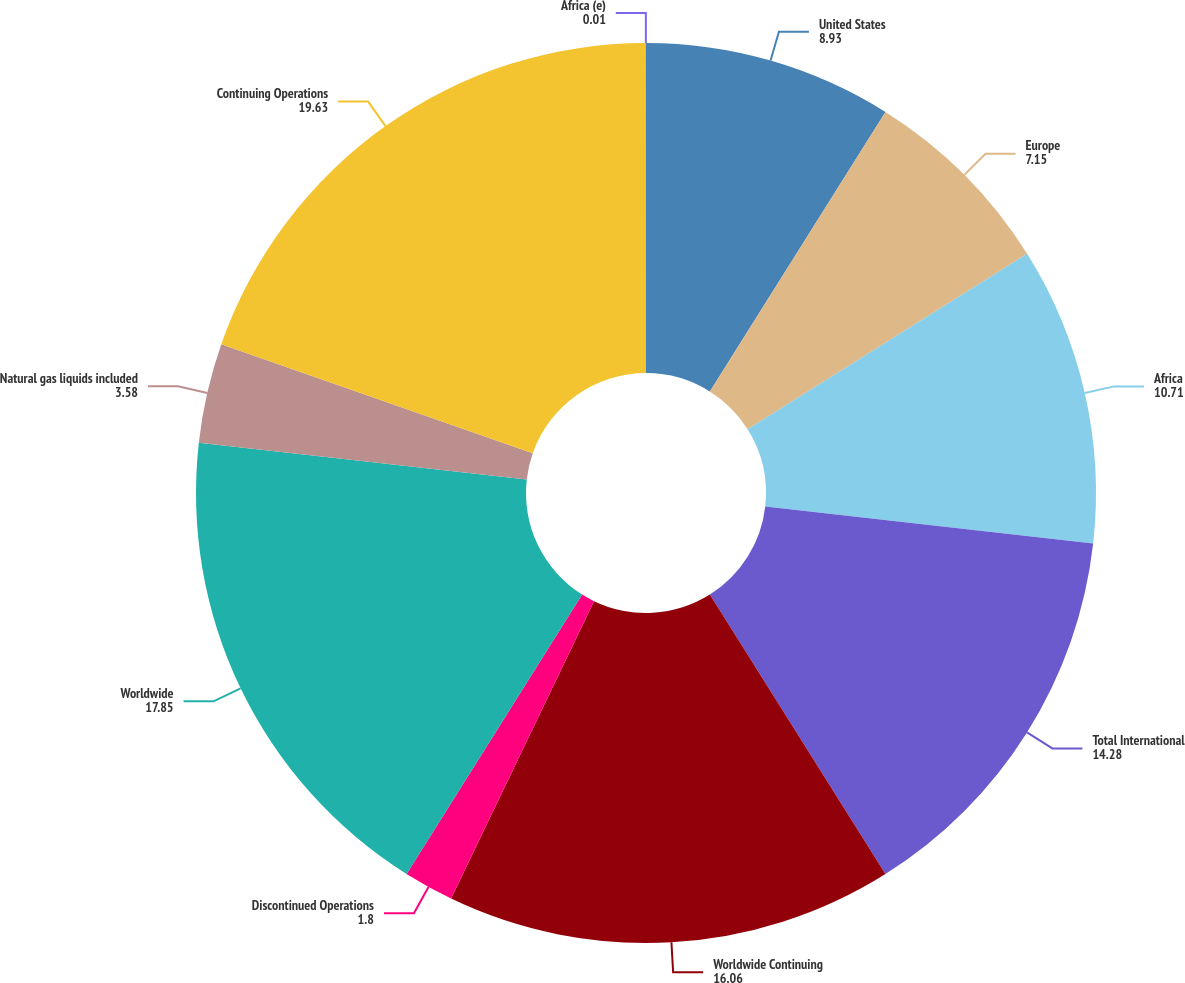Convert chart. <chart><loc_0><loc_0><loc_500><loc_500><pie_chart><fcel>United States<fcel>Europe<fcel>Africa<fcel>Total International<fcel>Worldwide Continuing<fcel>Discontinued Operations<fcel>Worldwide<fcel>Natural gas liquids included<fcel>Continuing Operations<fcel>Africa (e)<nl><fcel>8.93%<fcel>7.15%<fcel>10.71%<fcel>14.28%<fcel>16.06%<fcel>1.8%<fcel>17.85%<fcel>3.58%<fcel>19.63%<fcel>0.01%<nl></chart> 